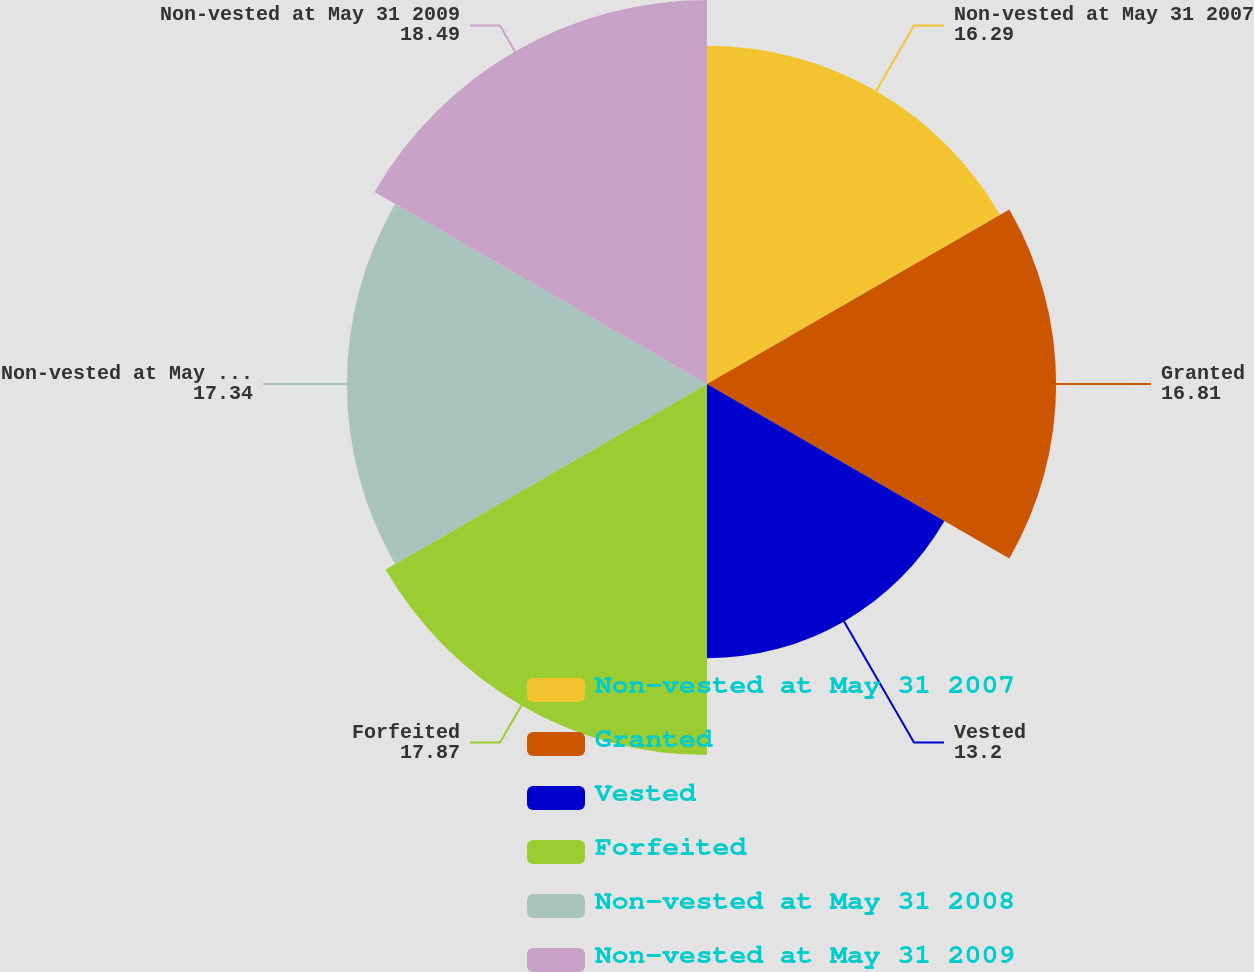Convert chart to OTSL. <chart><loc_0><loc_0><loc_500><loc_500><pie_chart><fcel>Non-vested at May 31 2007<fcel>Granted<fcel>Vested<fcel>Forfeited<fcel>Non-vested at May 31 2008<fcel>Non-vested at May 31 2009<nl><fcel>16.29%<fcel>16.81%<fcel>13.2%<fcel>17.87%<fcel>17.34%<fcel>18.49%<nl></chart> 